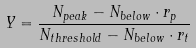Convert formula to latex. <formula><loc_0><loc_0><loc_500><loc_500>Y = \frac { N _ { p e a k } - N _ { b e l o w } \cdot r _ { p } } { N _ { t h r e s h o l d } - N _ { b e l o w } \cdot r _ { t } }</formula> 